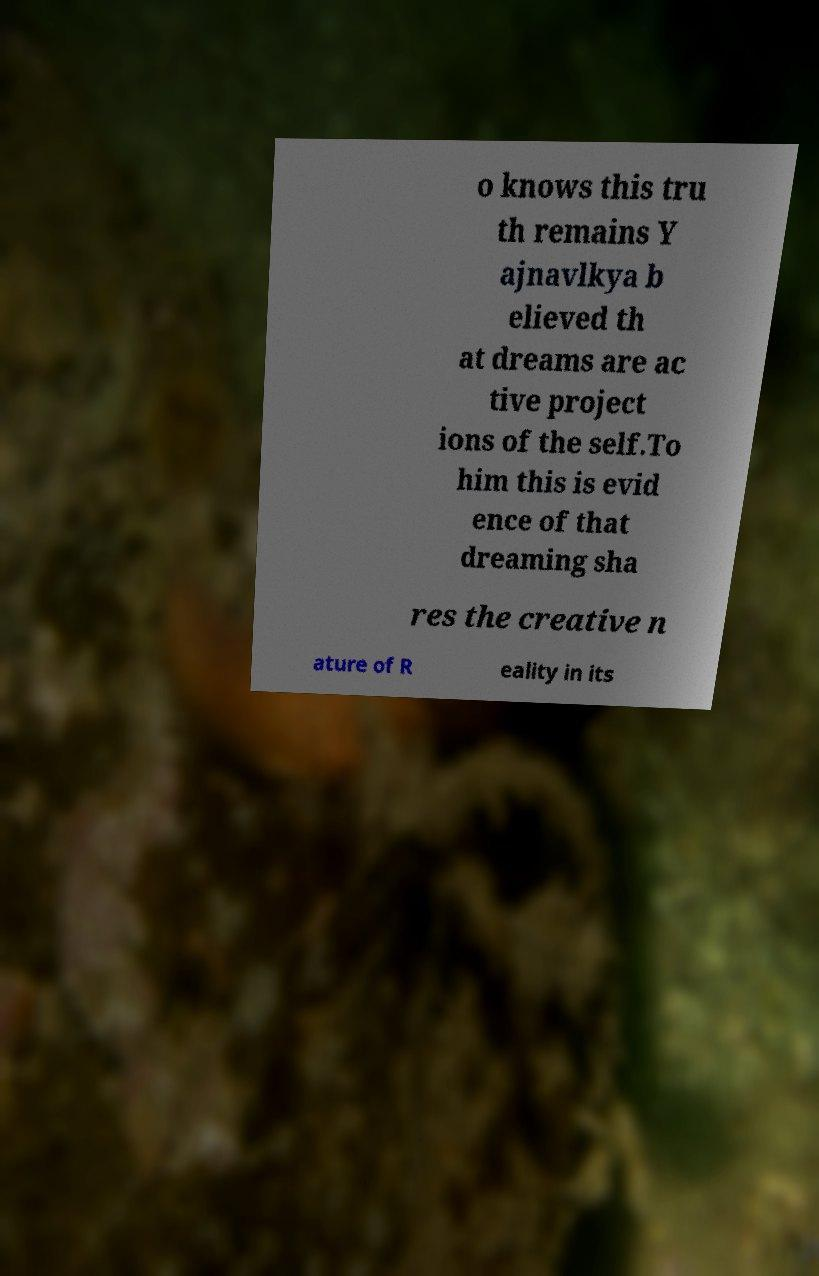Could you assist in decoding the text presented in this image and type it out clearly? o knows this tru th remains Y ajnavlkya b elieved th at dreams are ac tive project ions of the self.To him this is evid ence of that dreaming sha res the creative n ature of R eality in its 